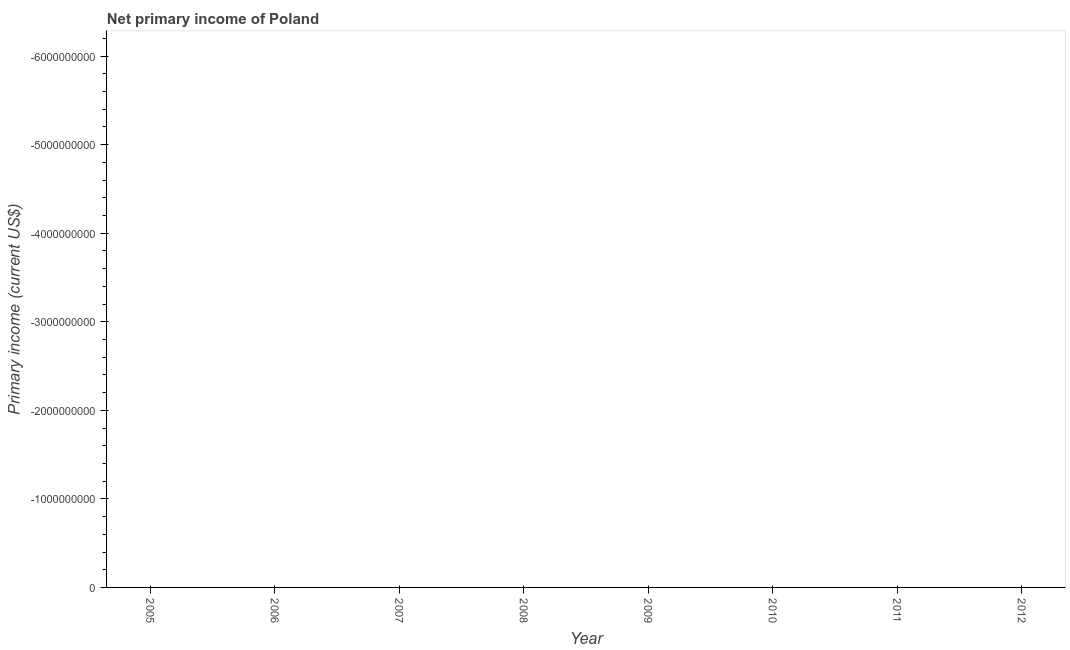What is the amount of primary income in 2011?
Keep it short and to the point. 0. What is the sum of the amount of primary income?
Make the answer very short. 0. What is the median amount of primary income?
Keep it short and to the point. 0. In how many years, is the amount of primary income greater than the average amount of primary income taken over all years?
Offer a very short reply. 0. Does the amount of primary income monotonically increase over the years?
Your answer should be very brief. No. How many lines are there?
Keep it short and to the point. 0. How many years are there in the graph?
Offer a terse response. 8. What is the difference between two consecutive major ticks on the Y-axis?
Provide a succinct answer. 1.00e+09. Are the values on the major ticks of Y-axis written in scientific E-notation?
Provide a succinct answer. No. What is the title of the graph?
Your response must be concise. Net primary income of Poland. What is the label or title of the X-axis?
Give a very brief answer. Year. What is the label or title of the Y-axis?
Your answer should be compact. Primary income (current US$). What is the Primary income (current US$) of 2009?
Keep it short and to the point. 0. What is the Primary income (current US$) of 2010?
Make the answer very short. 0. What is the Primary income (current US$) of 2011?
Your response must be concise. 0. 